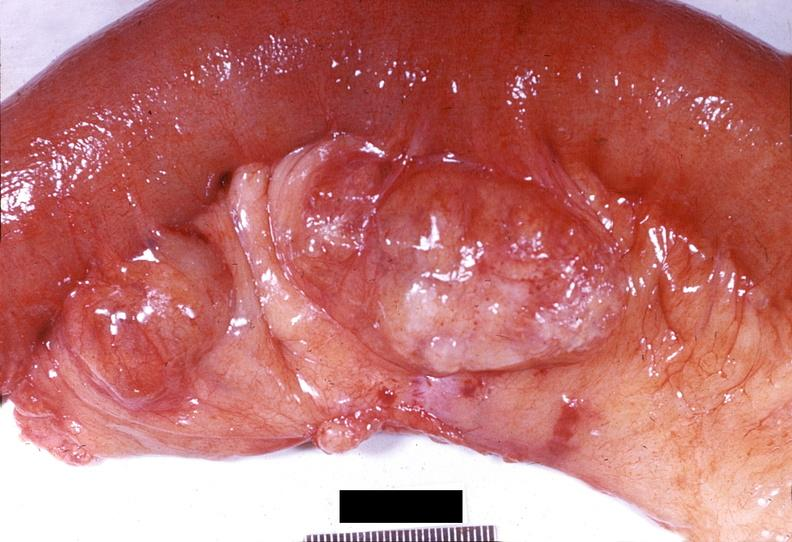does good example of muscle atrophy show gejunum, diverticula?
Answer the question using a single word or phrase. No 